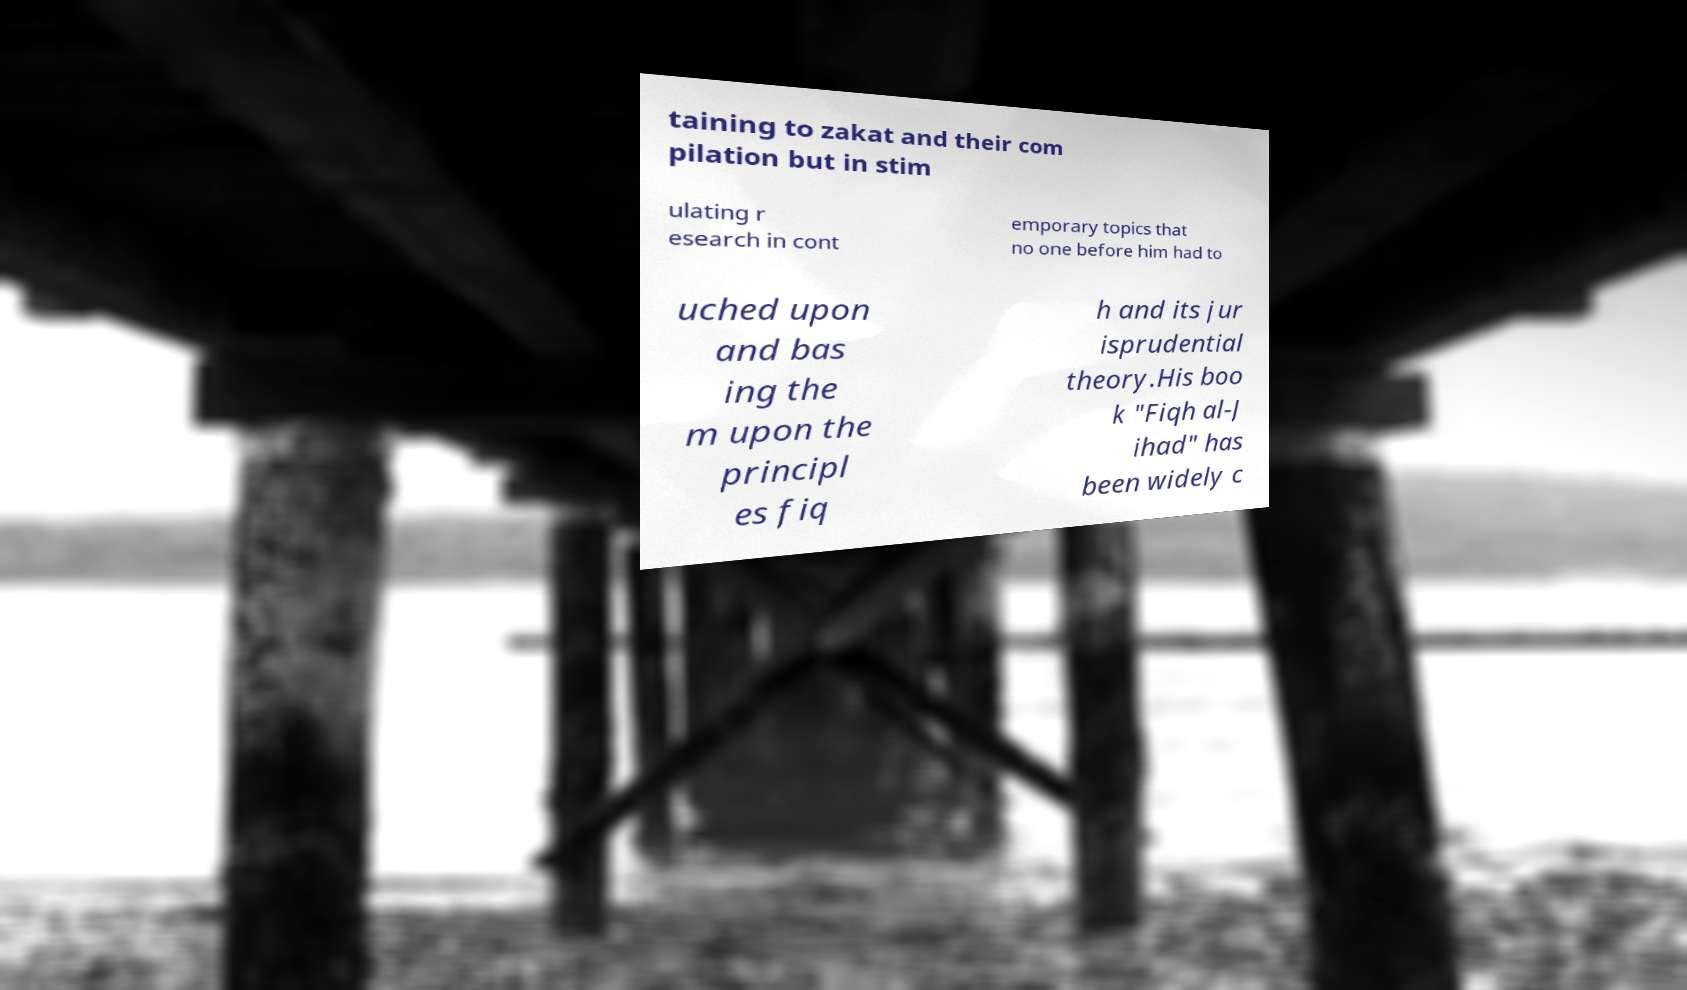Can you read and provide the text displayed in the image?This photo seems to have some interesting text. Can you extract and type it out for me? taining to zakat and their com pilation but in stim ulating r esearch in cont emporary topics that no one before him had to uched upon and bas ing the m upon the principl es fiq h and its jur isprudential theory.His boo k "Fiqh al-J ihad" has been widely c 